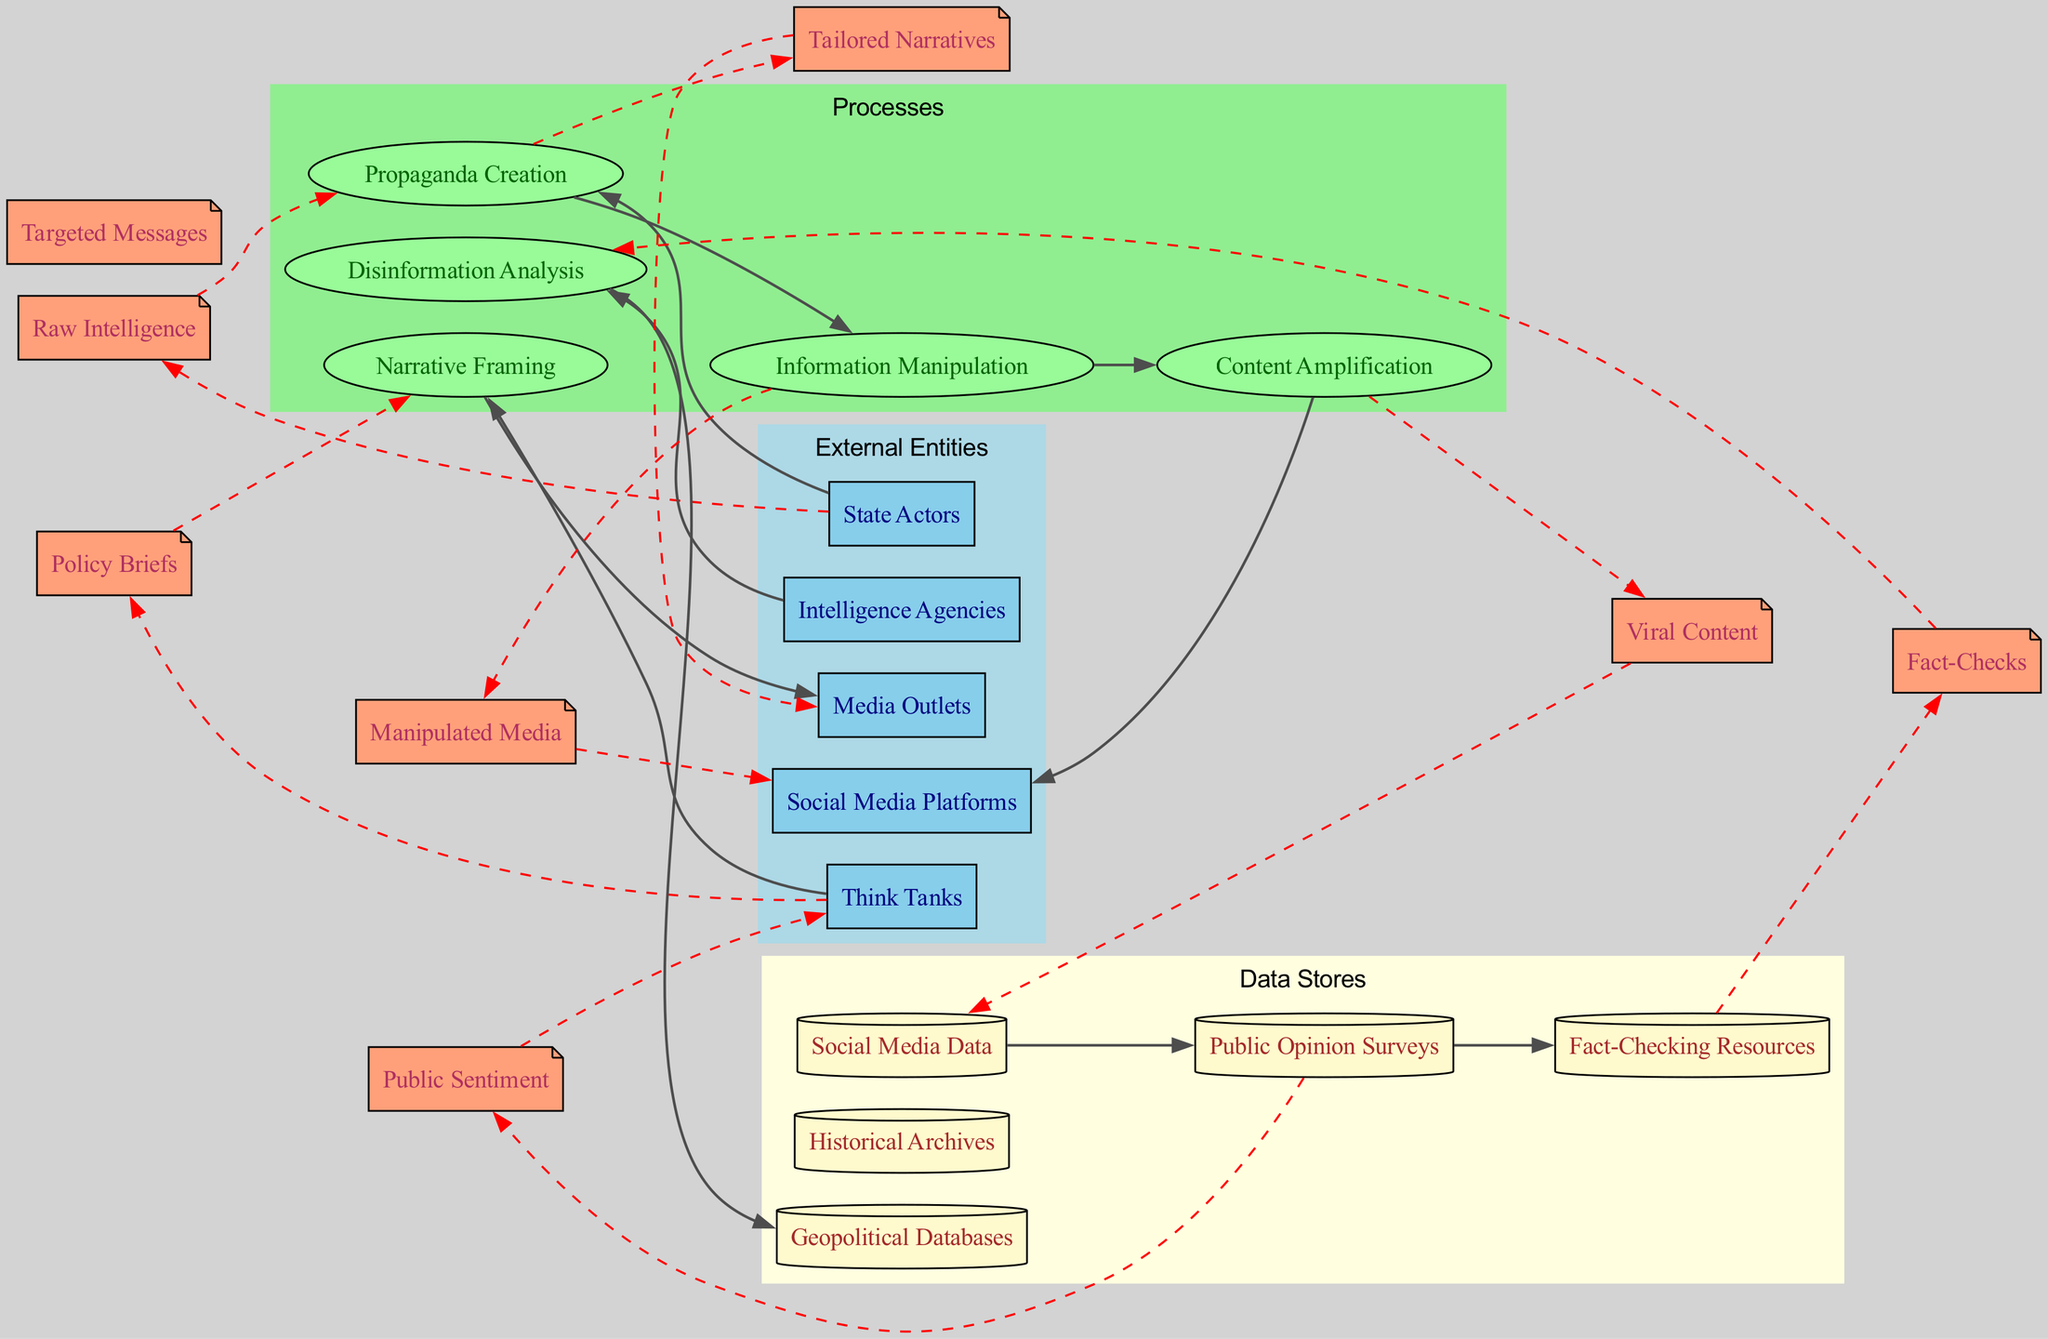What are the external entities represented in this diagram? The diagram includes five external entities, which are listed in the External Entities section: State Actors, Media Outlets, Social Media Platforms, Think Tanks, and Intelligence Agencies.
Answer: State Actors, Media Outlets, Social Media Platforms, Think Tanks, Intelligence Agencies How many processes are defined in the diagram? The diagram specifies five processes, which are found in the Processes section: Propaganda Creation, Information Manipulation, Disinformation Analysis, Content Amplification, and Narrative Framing.
Answer: 5 Which process is connected to Intelligence Agencies? The Intelligence Agencies process connects to the Disinformation Analysis process as shown in the connections.
Answer: Disinformation Analysis What type of data flow comes from Propaganda Creation? The data flow emerging from Propaganda Creation is labeled as Tailored Narratives, indicating the output from that process.
Answer: Tailored Narratives What connects Social Media Platforms to Content Amplification? The flow of data connections shows that Information Manipulation directly leads to Content Amplification, with Social Media Platforms being the destination of Amplified content.
Answer: Information Manipulation Which data store is linked to Public Opinion Surveys? The Public Opinion Surveys store is linked through a data flow to Social Media Data. The flow connection indicates that data transitions from Public Opinion Surveys toward Social Media data insights.
Answer: Social Media Data How is Narrative Framing influenced according to the diagram? Analysis shows that Narrative Framing is influenced by think tanks, which provide policy briefs, and then flows into Media Outlets. This indicates the dependency on think tanks for shaping narratives.
Answer: Think Tanks Which data flows towards Fact-Checking Resources? The flow is connected from Public Opinion Surveys to Fact-Checking Resources, indicating a route where data is utilized for verification processes.
Answer: Public Opinion Surveys How do State Actors initiate the diagram? State Actors initiate the process by providing Raw Intelligence, which serves as the input for the Propaganda Creation process, thus starting the flow of activities.
Answer: Raw Intelligence 